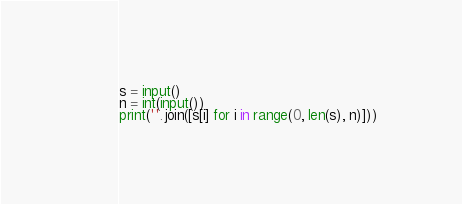Convert code to text. <code><loc_0><loc_0><loc_500><loc_500><_Python_>s = input()
n = int(input())
print(''.join([s[i] for i in range(0, len(s), n)]))
</code> 